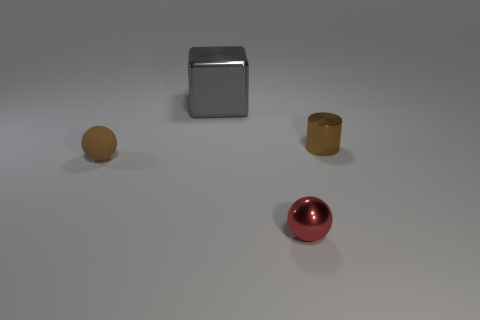Add 1 gray blocks. How many objects exist? 5 Subtract all blocks. How many objects are left? 3 Add 2 tiny brown balls. How many tiny brown balls exist? 3 Subtract 0 purple cylinders. How many objects are left? 4 Subtract all brown spheres. Subtract all brown rubber spheres. How many objects are left? 2 Add 2 gray shiny objects. How many gray shiny objects are left? 3 